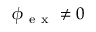Convert formula to latex. <formula><loc_0><loc_0><loc_500><loc_500>\boldsymbol _ { e x } \neq 0</formula> 